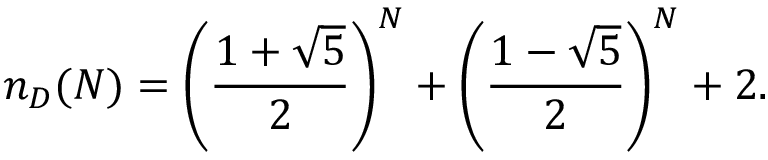<formula> <loc_0><loc_0><loc_500><loc_500>n _ { D } ( N ) = \left ( \frac { 1 + \sqrt { 5 } } { 2 } \right ) ^ { N } + \left ( \frac { 1 - \sqrt { 5 } } { 2 } \right ) ^ { N } + 2 .</formula> 